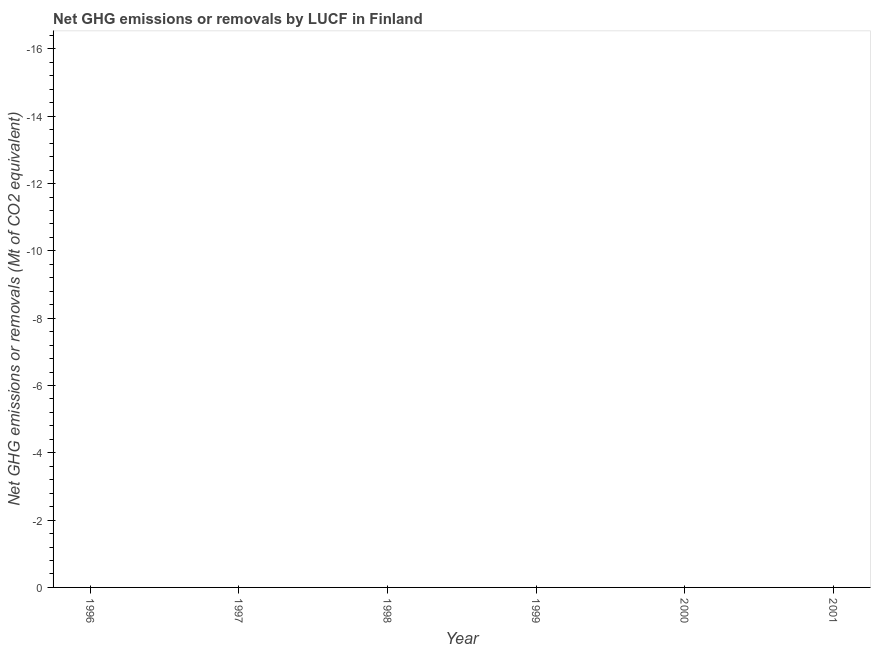What is the ghg net emissions or removals in 1996?
Provide a succinct answer. 0. Does the ghg net emissions or removals monotonically increase over the years?
Provide a short and direct response. No. How many years are there in the graph?
Offer a terse response. 6. What is the difference between two consecutive major ticks on the Y-axis?
Offer a very short reply. 2. Are the values on the major ticks of Y-axis written in scientific E-notation?
Your answer should be very brief. No. Does the graph contain any zero values?
Make the answer very short. Yes. What is the title of the graph?
Your answer should be very brief. Net GHG emissions or removals by LUCF in Finland. What is the label or title of the Y-axis?
Ensure brevity in your answer.  Net GHG emissions or removals (Mt of CO2 equivalent). What is the Net GHG emissions or removals (Mt of CO2 equivalent) of 1997?
Your answer should be very brief. 0. What is the Net GHG emissions or removals (Mt of CO2 equivalent) of 2000?
Provide a succinct answer. 0. 